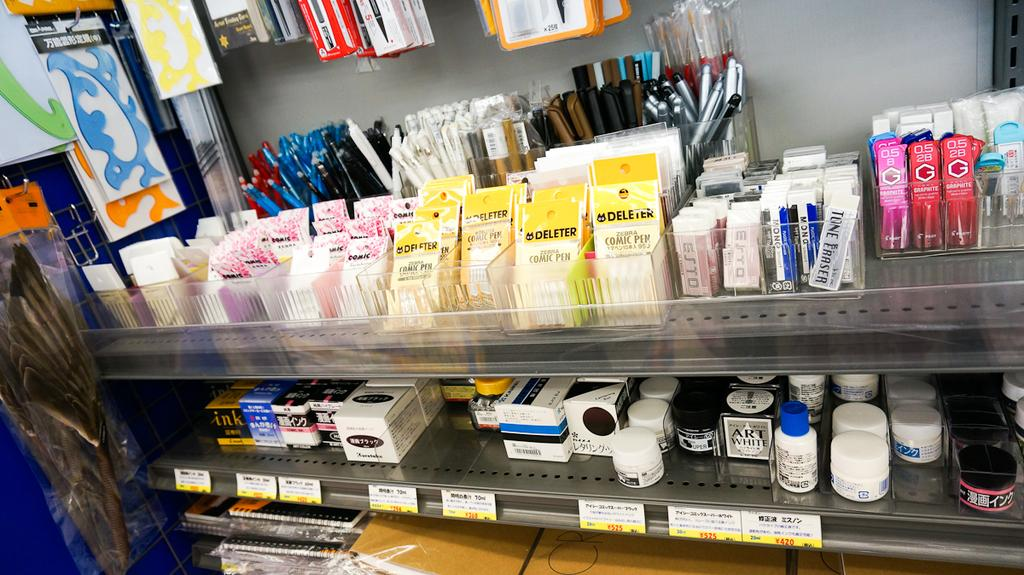<image>
Relay a brief, clear account of the picture shown. Many stationary items are on shelves, including Deleter comic pens. 